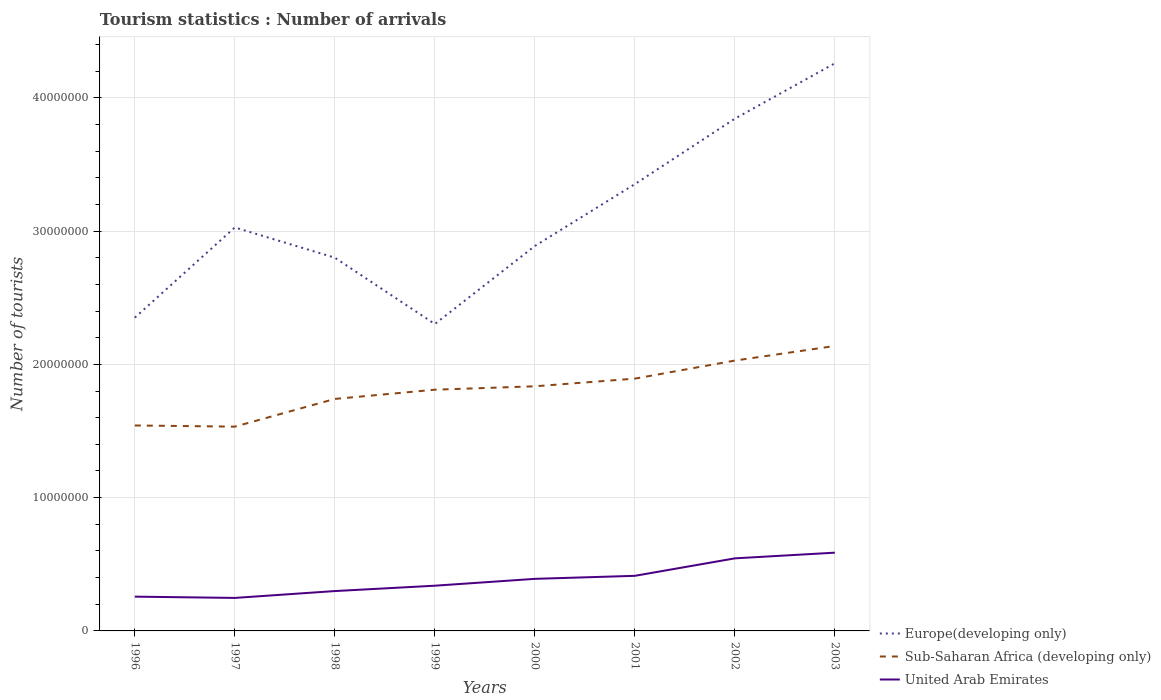Does the line corresponding to Europe(developing only) intersect with the line corresponding to United Arab Emirates?
Make the answer very short. No. Across all years, what is the maximum number of tourist arrivals in United Arab Emirates?
Offer a very short reply. 2.48e+06. In which year was the number of tourist arrivals in Sub-Saharan Africa (developing only) maximum?
Offer a very short reply. 1997. What is the total number of tourist arrivals in United Arab Emirates in the graph?
Offer a terse response. -3.30e+06. What is the difference between the highest and the second highest number of tourist arrivals in Europe(developing only)?
Your response must be concise. 1.96e+07. How many lines are there?
Provide a short and direct response. 3. How many years are there in the graph?
Provide a short and direct response. 8. What is the difference between two consecutive major ticks on the Y-axis?
Keep it short and to the point. 1.00e+07. Are the values on the major ticks of Y-axis written in scientific E-notation?
Make the answer very short. No. Does the graph contain any zero values?
Give a very brief answer. No. Where does the legend appear in the graph?
Your response must be concise. Bottom right. How many legend labels are there?
Your answer should be very brief. 3. How are the legend labels stacked?
Provide a short and direct response. Vertical. What is the title of the graph?
Offer a terse response. Tourism statistics : Number of arrivals. Does "East Asia (developing only)" appear as one of the legend labels in the graph?
Your answer should be compact. No. What is the label or title of the Y-axis?
Provide a succinct answer. Number of tourists. What is the Number of tourists in Europe(developing only) in 1996?
Offer a very short reply. 2.35e+07. What is the Number of tourists in Sub-Saharan Africa (developing only) in 1996?
Keep it short and to the point. 1.54e+07. What is the Number of tourists of United Arab Emirates in 1996?
Keep it short and to the point. 2.57e+06. What is the Number of tourists of Europe(developing only) in 1997?
Provide a short and direct response. 3.03e+07. What is the Number of tourists of Sub-Saharan Africa (developing only) in 1997?
Provide a short and direct response. 1.53e+07. What is the Number of tourists of United Arab Emirates in 1997?
Offer a very short reply. 2.48e+06. What is the Number of tourists of Europe(developing only) in 1998?
Your response must be concise. 2.80e+07. What is the Number of tourists in Sub-Saharan Africa (developing only) in 1998?
Keep it short and to the point. 1.74e+07. What is the Number of tourists in United Arab Emirates in 1998?
Offer a terse response. 2.99e+06. What is the Number of tourists of Europe(developing only) in 1999?
Your response must be concise. 2.30e+07. What is the Number of tourists of Sub-Saharan Africa (developing only) in 1999?
Provide a succinct answer. 1.81e+07. What is the Number of tourists in United Arab Emirates in 1999?
Ensure brevity in your answer.  3.39e+06. What is the Number of tourists of Europe(developing only) in 2000?
Your response must be concise. 2.89e+07. What is the Number of tourists of Sub-Saharan Africa (developing only) in 2000?
Provide a succinct answer. 1.84e+07. What is the Number of tourists of United Arab Emirates in 2000?
Provide a succinct answer. 3.91e+06. What is the Number of tourists in Europe(developing only) in 2001?
Your response must be concise. 3.35e+07. What is the Number of tourists of Sub-Saharan Africa (developing only) in 2001?
Provide a short and direct response. 1.89e+07. What is the Number of tourists of United Arab Emirates in 2001?
Ensure brevity in your answer.  4.13e+06. What is the Number of tourists of Europe(developing only) in 2002?
Your answer should be compact. 3.84e+07. What is the Number of tourists of Sub-Saharan Africa (developing only) in 2002?
Keep it short and to the point. 2.03e+07. What is the Number of tourists in United Arab Emirates in 2002?
Ensure brevity in your answer.  5.44e+06. What is the Number of tourists of Europe(developing only) in 2003?
Make the answer very short. 4.26e+07. What is the Number of tourists of Sub-Saharan Africa (developing only) in 2003?
Keep it short and to the point. 2.14e+07. What is the Number of tourists of United Arab Emirates in 2003?
Offer a terse response. 5.87e+06. Across all years, what is the maximum Number of tourists in Europe(developing only)?
Your answer should be very brief. 4.26e+07. Across all years, what is the maximum Number of tourists of Sub-Saharan Africa (developing only)?
Ensure brevity in your answer.  2.14e+07. Across all years, what is the maximum Number of tourists of United Arab Emirates?
Make the answer very short. 5.87e+06. Across all years, what is the minimum Number of tourists in Europe(developing only)?
Make the answer very short. 2.30e+07. Across all years, what is the minimum Number of tourists of Sub-Saharan Africa (developing only)?
Your answer should be very brief. 1.53e+07. Across all years, what is the minimum Number of tourists of United Arab Emirates?
Give a very brief answer. 2.48e+06. What is the total Number of tourists in Europe(developing only) in the graph?
Offer a very short reply. 2.48e+08. What is the total Number of tourists in Sub-Saharan Africa (developing only) in the graph?
Ensure brevity in your answer.  1.45e+08. What is the total Number of tourists of United Arab Emirates in the graph?
Make the answer very short. 3.08e+07. What is the difference between the Number of tourists in Europe(developing only) in 1996 and that in 1997?
Offer a very short reply. -6.77e+06. What is the difference between the Number of tourists of Sub-Saharan Africa (developing only) in 1996 and that in 1997?
Offer a very short reply. 8.85e+04. What is the difference between the Number of tourists of United Arab Emirates in 1996 and that in 1997?
Give a very brief answer. 9.60e+04. What is the difference between the Number of tourists in Europe(developing only) in 1996 and that in 1998?
Provide a short and direct response. -4.50e+06. What is the difference between the Number of tourists of Sub-Saharan Africa (developing only) in 1996 and that in 1998?
Your answer should be compact. -1.99e+06. What is the difference between the Number of tourists of United Arab Emirates in 1996 and that in 1998?
Your answer should be compact. -4.19e+05. What is the difference between the Number of tourists of Europe(developing only) in 1996 and that in 1999?
Make the answer very short. 4.79e+05. What is the difference between the Number of tourists in Sub-Saharan Africa (developing only) in 1996 and that in 1999?
Give a very brief answer. -2.68e+06. What is the difference between the Number of tourists in United Arab Emirates in 1996 and that in 1999?
Your answer should be compact. -8.21e+05. What is the difference between the Number of tourists in Europe(developing only) in 1996 and that in 2000?
Provide a short and direct response. -5.37e+06. What is the difference between the Number of tourists in Sub-Saharan Africa (developing only) in 1996 and that in 2000?
Your response must be concise. -2.94e+06. What is the difference between the Number of tourists in United Arab Emirates in 1996 and that in 2000?
Your answer should be very brief. -1.34e+06. What is the difference between the Number of tourists in Europe(developing only) in 1996 and that in 2001?
Offer a very short reply. -1.00e+07. What is the difference between the Number of tourists in Sub-Saharan Africa (developing only) in 1996 and that in 2001?
Provide a short and direct response. -3.51e+06. What is the difference between the Number of tourists of United Arab Emirates in 1996 and that in 2001?
Keep it short and to the point. -1.56e+06. What is the difference between the Number of tourists in Europe(developing only) in 1996 and that in 2002?
Keep it short and to the point. -1.49e+07. What is the difference between the Number of tourists in Sub-Saharan Africa (developing only) in 1996 and that in 2002?
Give a very brief answer. -4.87e+06. What is the difference between the Number of tourists in United Arab Emirates in 1996 and that in 2002?
Provide a succinct answer. -2.87e+06. What is the difference between the Number of tourists in Europe(developing only) in 1996 and that in 2003?
Your response must be concise. -1.91e+07. What is the difference between the Number of tourists of Sub-Saharan Africa (developing only) in 1996 and that in 2003?
Provide a short and direct response. -5.96e+06. What is the difference between the Number of tourists of United Arab Emirates in 1996 and that in 2003?
Offer a very short reply. -3.30e+06. What is the difference between the Number of tourists in Europe(developing only) in 1997 and that in 1998?
Make the answer very short. 2.27e+06. What is the difference between the Number of tourists in Sub-Saharan Africa (developing only) in 1997 and that in 1998?
Your answer should be very brief. -2.08e+06. What is the difference between the Number of tourists of United Arab Emirates in 1997 and that in 1998?
Your answer should be compact. -5.15e+05. What is the difference between the Number of tourists of Europe(developing only) in 1997 and that in 1999?
Your answer should be compact. 7.25e+06. What is the difference between the Number of tourists in Sub-Saharan Africa (developing only) in 1997 and that in 1999?
Your answer should be very brief. -2.77e+06. What is the difference between the Number of tourists of United Arab Emirates in 1997 and that in 1999?
Ensure brevity in your answer.  -9.17e+05. What is the difference between the Number of tourists in Europe(developing only) in 1997 and that in 2000?
Ensure brevity in your answer.  1.39e+06. What is the difference between the Number of tourists of Sub-Saharan Africa (developing only) in 1997 and that in 2000?
Give a very brief answer. -3.03e+06. What is the difference between the Number of tourists of United Arab Emirates in 1997 and that in 2000?
Give a very brief answer. -1.43e+06. What is the difference between the Number of tourists in Europe(developing only) in 1997 and that in 2001?
Provide a succinct answer. -3.25e+06. What is the difference between the Number of tourists of Sub-Saharan Africa (developing only) in 1997 and that in 2001?
Your answer should be very brief. -3.60e+06. What is the difference between the Number of tourists of United Arab Emirates in 1997 and that in 2001?
Your answer should be very brief. -1.66e+06. What is the difference between the Number of tourists of Europe(developing only) in 1997 and that in 2002?
Your answer should be compact. -8.16e+06. What is the difference between the Number of tourists in Sub-Saharan Africa (developing only) in 1997 and that in 2002?
Provide a succinct answer. -4.96e+06. What is the difference between the Number of tourists of United Arab Emirates in 1997 and that in 2002?
Offer a very short reply. -2.97e+06. What is the difference between the Number of tourists of Europe(developing only) in 1997 and that in 2003?
Provide a short and direct response. -1.23e+07. What is the difference between the Number of tourists of Sub-Saharan Africa (developing only) in 1997 and that in 2003?
Your answer should be compact. -6.05e+06. What is the difference between the Number of tourists of United Arab Emirates in 1997 and that in 2003?
Offer a terse response. -3.40e+06. What is the difference between the Number of tourists of Europe(developing only) in 1998 and that in 1999?
Your response must be concise. 4.98e+06. What is the difference between the Number of tourists of Sub-Saharan Africa (developing only) in 1998 and that in 1999?
Offer a very short reply. -6.92e+05. What is the difference between the Number of tourists of United Arab Emirates in 1998 and that in 1999?
Your response must be concise. -4.02e+05. What is the difference between the Number of tourists in Europe(developing only) in 1998 and that in 2000?
Provide a short and direct response. -8.76e+05. What is the difference between the Number of tourists in Sub-Saharan Africa (developing only) in 1998 and that in 2000?
Keep it short and to the point. -9.48e+05. What is the difference between the Number of tourists in United Arab Emirates in 1998 and that in 2000?
Make the answer very short. -9.16e+05. What is the difference between the Number of tourists of Europe(developing only) in 1998 and that in 2001?
Give a very brief answer. -5.52e+06. What is the difference between the Number of tourists of Sub-Saharan Africa (developing only) in 1998 and that in 2001?
Ensure brevity in your answer.  -1.52e+06. What is the difference between the Number of tourists of United Arab Emirates in 1998 and that in 2001?
Provide a succinct answer. -1.14e+06. What is the difference between the Number of tourists of Europe(developing only) in 1998 and that in 2002?
Provide a short and direct response. -1.04e+07. What is the difference between the Number of tourists in Sub-Saharan Africa (developing only) in 1998 and that in 2002?
Make the answer very short. -2.88e+06. What is the difference between the Number of tourists in United Arab Emirates in 1998 and that in 2002?
Offer a very short reply. -2.45e+06. What is the difference between the Number of tourists of Europe(developing only) in 1998 and that in 2003?
Provide a short and direct response. -1.46e+07. What is the difference between the Number of tourists in Sub-Saharan Africa (developing only) in 1998 and that in 2003?
Provide a short and direct response. -3.97e+06. What is the difference between the Number of tourists in United Arab Emirates in 1998 and that in 2003?
Keep it short and to the point. -2.88e+06. What is the difference between the Number of tourists in Europe(developing only) in 1999 and that in 2000?
Ensure brevity in your answer.  -5.85e+06. What is the difference between the Number of tourists of Sub-Saharan Africa (developing only) in 1999 and that in 2000?
Your answer should be very brief. -2.56e+05. What is the difference between the Number of tourists in United Arab Emirates in 1999 and that in 2000?
Give a very brief answer. -5.14e+05. What is the difference between the Number of tourists in Europe(developing only) in 1999 and that in 2001?
Your response must be concise. -1.05e+07. What is the difference between the Number of tourists in Sub-Saharan Africa (developing only) in 1999 and that in 2001?
Provide a succinct answer. -8.31e+05. What is the difference between the Number of tourists in United Arab Emirates in 1999 and that in 2001?
Provide a short and direct response. -7.41e+05. What is the difference between the Number of tourists of Europe(developing only) in 1999 and that in 2002?
Keep it short and to the point. -1.54e+07. What is the difference between the Number of tourists of Sub-Saharan Africa (developing only) in 1999 and that in 2002?
Your response must be concise. -2.19e+06. What is the difference between the Number of tourists of United Arab Emirates in 1999 and that in 2002?
Keep it short and to the point. -2.05e+06. What is the difference between the Number of tourists in Europe(developing only) in 1999 and that in 2003?
Offer a terse response. -1.96e+07. What is the difference between the Number of tourists in Sub-Saharan Africa (developing only) in 1999 and that in 2003?
Keep it short and to the point. -3.28e+06. What is the difference between the Number of tourists in United Arab Emirates in 1999 and that in 2003?
Offer a terse response. -2.48e+06. What is the difference between the Number of tourists of Europe(developing only) in 2000 and that in 2001?
Offer a terse response. -4.64e+06. What is the difference between the Number of tourists in Sub-Saharan Africa (developing only) in 2000 and that in 2001?
Ensure brevity in your answer.  -5.75e+05. What is the difference between the Number of tourists in United Arab Emirates in 2000 and that in 2001?
Provide a short and direct response. -2.27e+05. What is the difference between the Number of tourists in Europe(developing only) in 2000 and that in 2002?
Ensure brevity in your answer.  -9.55e+06. What is the difference between the Number of tourists of Sub-Saharan Africa (developing only) in 2000 and that in 2002?
Offer a very short reply. -1.93e+06. What is the difference between the Number of tourists of United Arab Emirates in 2000 and that in 2002?
Ensure brevity in your answer.  -1.54e+06. What is the difference between the Number of tourists in Europe(developing only) in 2000 and that in 2003?
Provide a succinct answer. -1.37e+07. What is the difference between the Number of tourists in Sub-Saharan Africa (developing only) in 2000 and that in 2003?
Make the answer very short. -3.03e+06. What is the difference between the Number of tourists in United Arab Emirates in 2000 and that in 2003?
Offer a very short reply. -1.96e+06. What is the difference between the Number of tourists in Europe(developing only) in 2001 and that in 2002?
Your response must be concise. -4.91e+06. What is the difference between the Number of tourists of Sub-Saharan Africa (developing only) in 2001 and that in 2002?
Provide a succinct answer. -1.35e+06. What is the difference between the Number of tourists of United Arab Emirates in 2001 and that in 2002?
Ensure brevity in your answer.  -1.31e+06. What is the difference between the Number of tourists in Europe(developing only) in 2001 and that in 2003?
Your response must be concise. -9.07e+06. What is the difference between the Number of tourists of Sub-Saharan Africa (developing only) in 2001 and that in 2003?
Provide a short and direct response. -2.45e+06. What is the difference between the Number of tourists in United Arab Emirates in 2001 and that in 2003?
Offer a very short reply. -1.74e+06. What is the difference between the Number of tourists in Europe(developing only) in 2002 and that in 2003?
Offer a very short reply. -4.16e+06. What is the difference between the Number of tourists in Sub-Saharan Africa (developing only) in 2002 and that in 2003?
Keep it short and to the point. -1.10e+06. What is the difference between the Number of tourists in United Arab Emirates in 2002 and that in 2003?
Provide a short and direct response. -4.26e+05. What is the difference between the Number of tourists in Europe(developing only) in 1996 and the Number of tourists in Sub-Saharan Africa (developing only) in 1997?
Make the answer very short. 8.18e+06. What is the difference between the Number of tourists in Europe(developing only) in 1996 and the Number of tourists in United Arab Emirates in 1997?
Your answer should be compact. 2.10e+07. What is the difference between the Number of tourists in Sub-Saharan Africa (developing only) in 1996 and the Number of tourists in United Arab Emirates in 1997?
Keep it short and to the point. 1.29e+07. What is the difference between the Number of tourists in Europe(developing only) in 1996 and the Number of tourists in Sub-Saharan Africa (developing only) in 1998?
Keep it short and to the point. 6.10e+06. What is the difference between the Number of tourists of Europe(developing only) in 1996 and the Number of tourists of United Arab Emirates in 1998?
Offer a very short reply. 2.05e+07. What is the difference between the Number of tourists of Sub-Saharan Africa (developing only) in 1996 and the Number of tourists of United Arab Emirates in 1998?
Make the answer very short. 1.24e+07. What is the difference between the Number of tourists of Europe(developing only) in 1996 and the Number of tourists of Sub-Saharan Africa (developing only) in 1999?
Ensure brevity in your answer.  5.41e+06. What is the difference between the Number of tourists in Europe(developing only) in 1996 and the Number of tourists in United Arab Emirates in 1999?
Provide a succinct answer. 2.01e+07. What is the difference between the Number of tourists of Sub-Saharan Africa (developing only) in 1996 and the Number of tourists of United Arab Emirates in 1999?
Your answer should be compact. 1.20e+07. What is the difference between the Number of tourists in Europe(developing only) in 1996 and the Number of tourists in Sub-Saharan Africa (developing only) in 2000?
Offer a terse response. 5.15e+06. What is the difference between the Number of tourists in Europe(developing only) in 1996 and the Number of tourists in United Arab Emirates in 2000?
Your answer should be very brief. 1.96e+07. What is the difference between the Number of tourists in Sub-Saharan Africa (developing only) in 1996 and the Number of tourists in United Arab Emirates in 2000?
Provide a short and direct response. 1.15e+07. What is the difference between the Number of tourists of Europe(developing only) in 1996 and the Number of tourists of Sub-Saharan Africa (developing only) in 2001?
Offer a terse response. 4.58e+06. What is the difference between the Number of tourists of Europe(developing only) in 1996 and the Number of tourists of United Arab Emirates in 2001?
Your answer should be compact. 1.94e+07. What is the difference between the Number of tourists of Sub-Saharan Africa (developing only) in 1996 and the Number of tourists of United Arab Emirates in 2001?
Your response must be concise. 1.13e+07. What is the difference between the Number of tourists of Europe(developing only) in 1996 and the Number of tourists of Sub-Saharan Africa (developing only) in 2002?
Keep it short and to the point. 3.22e+06. What is the difference between the Number of tourists of Europe(developing only) in 1996 and the Number of tourists of United Arab Emirates in 2002?
Make the answer very short. 1.81e+07. What is the difference between the Number of tourists in Sub-Saharan Africa (developing only) in 1996 and the Number of tourists in United Arab Emirates in 2002?
Your answer should be compact. 9.97e+06. What is the difference between the Number of tourists of Europe(developing only) in 1996 and the Number of tourists of Sub-Saharan Africa (developing only) in 2003?
Make the answer very short. 2.13e+06. What is the difference between the Number of tourists in Europe(developing only) in 1996 and the Number of tourists in United Arab Emirates in 2003?
Ensure brevity in your answer.  1.76e+07. What is the difference between the Number of tourists in Sub-Saharan Africa (developing only) in 1996 and the Number of tourists in United Arab Emirates in 2003?
Keep it short and to the point. 9.54e+06. What is the difference between the Number of tourists in Europe(developing only) in 1997 and the Number of tourists in Sub-Saharan Africa (developing only) in 1998?
Ensure brevity in your answer.  1.29e+07. What is the difference between the Number of tourists in Europe(developing only) in 1997 and the Number of tourists in United Arab Emirates in 1998?
Offer a terse response. 2.73e+07. What is the difference between the Number of tourists of Sub-Saharan Africa (developing only) in 1997 and the Number of tourists of United Arab Emirates in 1998?
Your answer should be compact. 1.23e+07. What is the difference between the Number of tourists of Europe(developing only) in 1997 and the Number of tourists of Sub-Saharan Africa (developing only) in 1999?
Make the answer very short. 1.22e+07. What is the difference between the Number of tourists of Europe(developing only) in 1997 and the Number of tourists of United Arab Emirates in 1999?
Ensure brevity in your answer.  2.69e+07. What is the difference between the Number of tourists in Sub-Saharan Africa (developing only) in 1997 and the Number of tourists in United Arab Emirates in 1999?
Offer a very short reply. 1.19e+07. What is the difference between the Number of tourists in Europe(developing only) in 1997 and the Number of tourists in Sub-Saharan Africa (developing only) in 2000?
Offer a very short reply. 1.19e+07. What is the difference between the Number of tourists in Europe(developing only) in 1997 and the Number of tourists in United Arab Emirates in 2000?
Provide a short and direct response. 2.64e+07. What is the difference between the Number of tourists in Sub-Saharan Africa (developing only) in 1997 and the Number of tourists in United Arab Emirates in 2000?
Provide a succinct answer. 1.14e+07. What is the difference between the Number of tourists of Europe(developing only) in 1997 and the Number of tourists of Sub-Saharan Africa (developing only) in 2001?
Offer a very short reply. 1.13e+07. What is the difference between the Number of tourists in Europe(developing only) in 1997 and the Number of tourists in United Arab Emirates in 2001?
Offer a very short reply. 2.61e+07. What is the difference between the Number of tourists in Sub-Saharan Africa (developing only) in 1997 and the Number of tourists in United Arab Emirates in 2001?
Your answer should be compact. 1.12e+07. What is the difference between the Number of tourists of Europe(developing only) in 1997 and the Number of tourists of Sub-Saharan Africa (developing only) in 2002?
Give a very brief answer. 9.99e+06. What is the difference between the Number of tourists of Europe(developing only) in 1997 and the Number of tourists of United Arab Emirates in 2002?
Offer a terse response. 2.48e+07. What is the difference between the Number of tourists of Sub-Saharan Africa (developing only) in 1997 and the Number of tourists of United Arab Emirates in 2002?
Your response must be concise. 9.88e+06. What is the difference between the Number of tourists in Europe(developing only) in 1997 and the Number of tourists in Sub-Saharan Africa (developing only) in 2003?
Provide a succinct answer. 8.89e+06. What is the difference between the Number of tourists of Europe(developing only) in 1997 and the Number of tourists of United Arab Emirates in 2003?
Provide a short and direct response. 2.44e+07. What is the difference between the Number of tourists in Sub-Saharan Africa (developing only) in 1997 and the Number of tourists in United Arab Emirates in 2003?
Offer a terse response. 9.46e+06. What is the difference between the Number of tourists of Europe(developing only) in 1998 and the Number of tourists of Sub-Saharan Africa (developing only) in 1999?
Provide a succinct answer. 9.91e+06. What is the difference between the Number of tourists of Europe(developing only) in 1998 and the Number of tourists of United Arab Emirates in 1999?
Keep it short and to the point. 2.46e+07. What is the difference between the Number of tourists of Sub-Saharan Africa (developing only) in 1998 and the Number of tourists of United Arab Emirates in 1999?
Offer a very short reply. 1.40e+07. What is the difference between the Number of tourists of Europe(developing only) in 1998 and the Number of tourists of Sub-Saharan Africa (developing only) in 2000?
Make the answer very short. 9.65e+06. What is the difference between the Number of tourists in Europe(developing only) in 1998 and the Number of tourists in United Arab Emirates in 2000?
Give a very brief answer. 2.41e+07. What is the difference between the Number of tourists in Sub-Saharan Africa (developing only) in 1998 and the Number of tourists in United Arab Emirates in 2000?
Provide a short and direct response. 1.35e+07. What is the difference between the Number of tourists of Europe(developing only) in 1998 and the Number of tourists of Sub-Saharan Africa (developing only) in 2001?
Give a very brief answer. 9.07e+06. What is the difference between the Number of tourists of Europe(developing only) in 1998 and the Number of tourists of United Arab Emirates in 2001?
Your response must be concise. 2.39e+07. What is the difference between the Number of tourists in Sub-Saharan Africa (developing only) in 1998 and the Number of tourists in United Arab Emirates in 2001?
Offer a very short reply. 1.33e+07. What is the difference between the Number of tourists in Europe(developing only) in 1998 and the Number of tourists in Sub-Saharan Africa (developing only) in 2002?
Make the answer very short. 7.72e+06. What is the difference between the Number of tourists in Europe(developing only) in 1998 and the Number of tourists in United Arab Emirates in 2002?
Give a very brief answer. 2.26e+07. What is the difference between the Number of tourists in Sub-Saharan Africa (developing only) in 1998 and the Number of tourists in United Arab Emirates in 2002?
Your answer should be compact. 1.20e+07. What is the difference between the Number of tourists in Europe(developing only) in 1998 and the Number of tourists in Sub-Saharan Africa (developing only) in 2003?
Offer a very short reply. 6.62e+06. What is the difference between the Number of tourists in Europe(developing only) in 1998 and the Number of tourists in United Arab Emirates in 2003?
Your answer should be compact. 2.21e+07. What is the difference between the Number of tourists of Sub-Saharan Africa (developing only) in 1998 and the Number of tourists of United Arab Emirates in 2003?
Your answer should be very brief. 1.15e+07. What is the difference between the Number of tourists of Europe(developing only) in 1999 and the Number of tourists of Sub-Saharan Africa (developing only) in 2000?
Provide a short and direct response. 4.67e+06. What is the difference between the Number of tourists of Europe(developing only) in 1999 and the Number of tourists of United Arab Emirates in 2000?
Your response must be concise. 1.91e+07. What is the difference between the Number of tourists of Sub-Saharan Africa (developing only) in 1999 and the Number of tourists of United Arab Emirates in 2000?
Your response must be concise. 1.42e+07. What is the difference between the Number of tourists in Europe(developing only) in 1999 and the Number of tourists in Sub-Saharan Africa (developing only) in 2001?
Make the answer very short. 4.10e+06. What is the difference between the Number of tourists in Europe(developing only) in 1999 and the Number of tourists in United Arab Emirates in 2001?
Provide a succinct answer. 1.89e+07. What is the difference between the Number of tourists of Sub-Saharan Africa (developing only) in 1999 and the Number of tourists of United Arab Emirates in 2001?
Offer a terse response. 1.40e+07. What is the difference between the Number of tourists in Europe(developing only) in 1999 and the Number of tourists in Sub-Saharan Africa (developing only) in 2002?
Your answer should be compact. 2.74e+06. What is the difference between the Number of tourists in Europe(developing only) in 1999 and the Number of tourists in United Arab Emirates in 2002?
Your response must be concise. 1.76e+07. What is the difference between the Number of tourists in Sub-Saharan Africa (developing only) in 1999 and the Number of tourists in United Arab Emirates in 2002?
Keep it short and to the point. 1.27e+07. What is the difference between the Number of tourists in Europe(developing only) in 1999 and the Number of tourists in Sub-Saharan Africa (developing only) in 2003?
Provide a short and direct response. 1.65e+06. What is the difference between the Number of tourists in Europe(developing only) in 1999 and the Number of tourists in United Arab Emirates in 2003?
Keep it short and to the point. 1.72e+07. What is the difference between the Number of tourists of Sub-Saharan Africa (developing only) in 1999 and the Number of tourists of United Arab Emirates in 2003?
Make the answer very short. 1.22e+07. What is the difference between the Number of tourists of Europe(developing only) in 2000 and the Number of tourists of Sub-Saharan Africa (developing only) in 2001?
Your response must be concise. 9.95e+06. What is the difference between the Number of tourists of Europe(developing only) in 2000 and the Number of tourists of United Arab Emirates in 2001?
Ensure brevity in your answer.  2.47e+07. What is the difference between the Number of tourists of Sub-Saharan Africa (developing only) in 2000 and the Number of tourists of United Arab Emirates in 2001?
Ensure brevity in your answer.  1.42e+07. What is the difference between the Number of tourists of Europe(developing only) in 2000 and the Number of tourists of Sub-Saharan Africa (developing only) in 2002?
Your answer should be very brief. 8.60e+06. What is the difference between the Number of tourists in Europe(developing only) in 2000 and the Number of tourists in United Arab Emirates in 2002?
Provide a succinct answer. 2.34e+07. What is the difference between the Number of tourists in Sub-Saharan Africa (developing only) in 2000 and the Number of tourists in United Arab Emirates in 2002?
Offer a terse response. 1.29e+07. What is the difference between the Number of tourists in Europe(developing only) in 2000 and the Number of tourists in Sub-Saharan Africa (developing only) in 2003?
Offer a terse response. 7.50e+06. What is the difference between the Number of tourists of Europe(developing only) in 2000 and the Number of tourists of United Arab Emirates in 2003?
Offer a terse response. 2.30e+07. What is the difference between the Number of tourists in Sub-Saharan Africa (developing only) in 2000 and the Number of tourists in United Arab Emirates in 2003?
Provide a succinct answer. 1.25e+07. What is the difference between the Number of tourists of Europe(developing only) in 2001 and the Number of tourists of Sub-Saharan Africa (developing only) in 2002?
Your answer should be compact. 1.32e+07. What is the difference between the Number of tourists of Europe(developing only) in 2001 and the Number of tourists of United Arab Emirates in 2002?
Offer a very short reply. 2.81e+07. What is the difference between the Number of tourists of Sub-Saharan Africa (developing only) in 2001 and the Number of tourists of United Arab Emirates in 2002?
Keep it short and to the point. 1.35e+07. What is the difference between the Number of tourists of Europe(developing only) in 2001 and the Number of tourists of Sub-Saharan Africa (developing only) in 2003?
Provide a succinct answer. 1.21e+07. What is the difference between the Number of tourists of Europe(developing only) in 2001 and the Number of tourists of United Arab Emirates in 2003?
Give a very brief answer. 2.77e+07. What is the difference between the Number of tourists of Sub-Saharan Africa (developing only) in 2001 and the Number of tourists of United Arab Emirates in 2003?
Provide a succinct answer. 1.31e+07. What is the difference between the Number of tourists of Europe(developing only) in 2002 and the Number of tourists of Sub-Saharan Africa (developing only) in 2003?
Make the answer very short. 1.71e+07. What is the difference between the Number of tourists in Europe(developing only) in 2002 and the Number of tourists in United Arab Emirates in 2003?
Give a very brief answer. 3.26e+07. What is the difference between the Number of tourists of Sub-Saharan Africa (developing only) in 2002 and the Number of tourists of United Arab Emirates in 2003?
Give a very brief answer. 1.44e+07. What is the average Number of tourists in Europe(developing only) per year?
Offer a terse response. 3.10e+07. What is the average Number of tourists of Sub-Saharan Africa (developing only) per year?
Provide a succinct answer. 1.81e+07. What is the average Number of tourists in United Arab Emirates per year?
Ensure brevity in your answer.  3.85e+06. In the year 1996, what is the difference between the Number of tourists of Europe(developing only) and Number of tourists of Sub-Saharan Africa (developing only)?
Your response must be concise. 8.09e+06. In the year 1996, what is the difference between the Number of tourists in Europe(developing only) and Number of tourists in United Arab Emirates?
Ensure brevity in your answer.  2.09e+07. In the year 1996, what is the difference between the Number of tourists in Sub-Saharan Africa (developing only) and Number of tourists in United Arab Emirates?
Offer a very short reply. 1.28e+07. In the year 1997, what is the difference between the Number of tourists in Europe(developing only) and Number of tourists in Sub-Saharan Africa (developing only)?
Ensure brevity in your answer.  1.49e+07. In the year 1997, what is the difference between the Number of tourists of Europe(developing only) and Number of tourists of United Arab Emirates?
Give a very brief answer. 2.78e+07. In the year 1997, what is the difference between the Number of tourists of Sub-Saharan Africa (developing only) and Number of tourists of United Arab Emirates?
Ensure brevity in your answer.  1.29e+07. In the year 1998, what is the difference between the Number of tourists in Europe(developing only) and Number of tourists in Sub-Saharan Africa (developing only)?
Keep it short and to the point. 1.06e+07. In the year 1998, what is the difference between the Number of tourists of Europe(developing only) and Number of tourists of United Arab Emirates?
Give a very brief answer. 2.50e+07. In the year 1998, what is the difference between the Number of tourists in Sub-Saharan Africa (developing only) and Number of tourists in United Arab Emirates?
Your answer should be compact. 1.44e+07. In the year 1999, what is the difference between the Number of tourists of Europe(developing only) and Number of tourists of Sub-Saharan Africa (developing only)?
Your answer should be compact. 4.93e+06. In the year 1999, what is the difference between the Number of tourists in Europe(developing only) and Number of tourists in United Arab Emirates?
Offer a terse response. 1.96e+07. In the year 1999, what is the difference between the Number of tourists of Sub-Saharan Africa (developing only) and Number of tourists of United Arab Emirates?
Ensure brevity in your answer.  1.47e+07. In the year 2000, what is the difference between the Number of tourists in Europe(developing only) and Number of tourists in Sub-Saharan Africa (developing only)?
Offer a very short reply. 1.05e+07. In the year 2000, what is the difference between the Number of tourists of Europe(developing only) and Number of tourists of United Arab Emirates?
Make the answer very short. 2.50e+07. In the year 2000, what is the difference between the Number of tourists of Sub-Saharan Africa (developing only) and Number of tourists of United Arab Emirates?
Keep it short and to the point. 1.44e+07. In the year 2001, what is the difference between the Number of tourists in Europe(developing only) and Number of tourists in Sub-Saharan Africa (developing only)?
Your response must be concise. 1.46e+07. In the year 2001, what is the difference between the Number of tourists in Europe(developing only) and Number of tourists in United Arab Emirates?
Provide a succinct answer. 2.94e+07. In the year 2001, what is the difference between the Number of tourists of Sub-Saharan Africa (developing only) and Number of tourists of United Arab Emirates?
Offer a very short reply. 1.48e+07. In the year 2002, what is the difference between the Number of tourists of Europe(developing only) and Number of tourists of Sub-Saharan Africa (developing only)?
Offer a terse response. 1.81e+07. In the year 2002, what is the difference between the Number of tourists of Europe(developing only) and Number of tourists of United Arab Emirates?
Give a very brief answer. 3.30e+07. In the year 2002, what is the difference between the Number of tourists in Sub-Saharan Africa (developing only) and Number of tourists in United Arab Emirates?
Provide a short and direct response. 1.48e+07. In the year 2003, what is the difference between the Number of tourists of Europe(developing only) and Number of tourists of Sub-Saharan Africa (developing only)?
Ensure brevity in your answer.  2.12e+07. In the year 2003, what is the difference between the Number of tourists of Europe(developing only) and Number of tourists of United Arab Emirates?
Give a very brief answer. 3.67e+07. In the year 2003, what is the difference between the Number of tourists in Sub-Saharan Africa (developing only) and Number of tourists in United Arab Emirates?
Offer a very short reply. 1.55e+07. What is the ratio of the Number of tourists in Europe(developing only) in 1996 to that in 1997?
Keep it short and to the point. 0.78. What is the ratio of the Number of tourists in United Arab Emirates in 1996 to that in 1997?
Give a very brief answer. 1.04. What is the ratio of the Number of tourists of Europe(developing only) in 1996 to that in 1998?
Ensure brevity in your answer.  0.84. What is the ratio of the Number of tourists of Sub-Saharan Africa (developing only) in 1996 to that in 1998?
Provide a short and direct response. 0.89. What is the ratio of the Number of tourists of United Arab Emirates in 1996 to that in 1998?
Provide a short and direct response. 0.86. What is the ratio of the Number of tourists in Europe(developing only) in 1996 to that in 1999?
Ensure brevity in your answer.  1.02. What is the ratio of the Number of tourists of Sub-Saharan Africa (developing only) in 1996 to that in 1999?
Your answer should be compact. 0.85. What is the ratio of the Number of tourists in United Arab Emirates in 1996 to that in 1999?
Give a very brief answer. 0.76. What is the ratio of the Number of tourists in Europe(developing only) in 1996 to that in 2000?
Offer a very short reply. 0.81. What is the ratio of the Number of tourists in Sub-Saharan Africa (developing only) in 1996 to that in 2000?
Ensure brevity in your answer.  0.84. What is the ratio of the Number of tourists in United Arab Emirates in 1996 to that in 2000?
Your response must be concise. 0.66. What is the ratio of the Number of tourists in Europe(developing only) in 1996 to that in 2001?
Your answer should be compact. 0.7. What is the ratio of the Number of tourists of Sub-Saharan Africa (developing only) in 1996 to that in 2001?
Your response must be concise. 0.81. What is the ratio of the Number of tourists of United Arab Emirates in 1996 to that in 2001?
Provide a short and direct response. 0.62. What is the ratio of the Number of tourists in Europe(developing only) in 1996 to that in 2002?
Your answer should be compact. 0.61. What is the ratio of the Number of tourists in Sub-Saharan Africa (developing only) in 1996 to that in 2002?
Ensure brevity in your answer.  0.76. What is the ratio of the Number of tourists in United Arab Emirates in 1996 to that in 2002?
Offer a terse response. 0.47. What is the ratio of the Number of tourists of Europe(developing only) in 1996 to that in 2003?
Provide a short and direct response. 0.55. What is the ratio of the Number of tourists of Sub-Saharan Africa (developing only) in 1996 to that in 2003?
Give a very brief answer. 0.72. What is the ratio of the Number of tourists in United Arab Emirates in 1996 to that in 2003?
Your answer should be compact. 0.44. What is the ratio of the Number of tourists in Europe(developing only) in 1997 to that in 1998?
Keep it short and to the point. 1.08. What is the ratio of the Number of tourists of Sub-Saharan Africa (developing only) in 1997 to that in 1998?
Your answer should be compact. 0.88. What is the ratio of the Number of tourists in United Arab Emirates in 1997 to that in 1998?
Offer a very short reply. 0.83. What is the ratio of the Number of tourists in Europe(developing only) in 1997 to that in 1999?
Your response must be concise. 1.31. What is the ratio of the Number of tourists of Sub-Saharan Africa (developing only) in 1997 to that in 1999?
Your response must be concise. 0.85. What is the ratio of the Number of tourists in United Arab Emirates in 1997 to that in 1999?
Your answer should be very brief. 0.73. What is the ratio of the Number of tourists in Europe(developing only) in 1997 to that in 2000?
Your answer should be very brief. 1.05. What is the ratio of the Number of tourists in Sub-Saharan Africa (developing only) in 1997 to that in 2000?
Offer a terse response. 0.84. What is the ratio of the Number of tourists in United Arab Emirates in 1997 to that in 2000?
Provide a succinct answer. 0.63. What is the ratio of the Number of tourists of Europe(developing only) in 1997 to that in 2001?
Your answer should be very brief. 0.9. What is the ratio of the Number of tourists of Sub-Saharan Africa (developing only) in 1997 to that in 2001?
Make the answer very short. 0.81. What is the ratio of the Number of tourists of United Arab Emirates in 1997 to that in 2001?
Give a very brief answer. 0.6. What is the ratio of the Number of tourists of Europe(developing only) in 1997 to that in 2002?
Your answer should be very brief. 0.79. What is the ratio of the Number of tourists of Sub-Saharan Africa (developing only) in 1997 to that in 2002?
Provide a succinct answer. 0.76. What is the ratio of the Number of tourists of United Arab Emirates in 1997 to that in 2002?
Provide a succinct answer. 0.45. What is the ratio of the Number of tourists of Europe(developing only) in 1997 to that in 2003?
Make the answer very short. 0.71. What is the ratio of the Number of tourists of Sub-Saharan Africa (developing only) in 1997 to that in 2003?
Provide a succinct answer. 0.72. What is the ratio of the Number of tourists in United Arab Emirates in 1997 to that in 2003?
Provide a succinct answer. 0.42. What is the ratio of the Number of tourists of Europe(developing only) in 1998 to that in 1999?
Your answer should be very brief. 1.22. What is the ratio of the Number of tourists of Sub-Saharan Africa (developing only) in 1998 to that in 1999?
Ensure brevity in your answer.  0.96. What is the ratio of the Number of tourists of United Arab Emirates in 1998 to that in 1999?
Offer a terse response. 0.88. What is the ratio of the Number of tourists of Europe(developing only) in 1998 to that in 2000?
Give a very brief answer. 0.97. What is the ratio of the Number of tourists in Sub-Saharan Africa (developing only) in 1998 to that in 2000?
Keep it short and to the point. 0.95. What is the ratio of the Number of tourists in United Arab Emirates in 1998 to that in 2000?
Provide a succinct answer. 0.77. What is the ratio of the Number of tourists in Europe(developing only) in 1998 to that in 2001?
Offer a terse response. 0.84. What is the ratio of the Number of tourists of Sub-Saharan Africa (developing only) in 1998 to that in 2001?
Offer a very short reply. 0.92. What is the ratio of the Number of tourists in United Arab Emirates in 1998 to that in 2001?
Your answer should be compact. 0.72. What is the ratio of the Number of tourists of Europe(developing only) in 1998 to that in 2002?
Provide a succinct answer. 0.73. What is the ratio of the Number of tourists of Sub-Saharan Africa (developing only) in 1998 to that in 2002?
Offer a very short reply. 0.86. What is the ratio of the Number of tourists in United Arab Emirates in 1998 to that in 2002?
Your response must be concise. 0.55. What is the ratio of the Number of tourists of Europe(developing only) in 1998 to that in 2003?
Your answer should be compact. 0.66. What is the ratio of the Number of tourists of Sub-Saharan Africa (developing only) in 1998 to that in 2003?
Your answer should be very brief. 0.81. What is the ratio of the Number of tourists of United Arab Emirates in 1998 to that in 2003?
Provide a short and direct response. 0.51. What is the ratio of the Number of tourists of Europe(developing only) in 1999 to that in 2000?
Your response must be concise. 0.8. What is the ratio of the Number of tourists of Sub-Saharan Africa (developing only) in 1999 to that in 2000?
Provide a short and direct response. 0.99. What is the ratio of the Number of tourists in United Arab Emirates in 1999 to that in 2000?
Keep it short and to the point. 0.87. What is the ratio of the Number of tourists in Europe(developing only) in 1999 to that in 2001?
Offer a terse response. 0.69. What is the ratio of the Number of tourists in Sub-Saharan Africa (developing only) in 1999 to that in 2001?
Your answer should be very brief. 0.96. What is the ratio of the Number of tourists in United Arab Emirates in 1999 to that in 2001?
Keep it short and to the point. 0.82. What is the ratio of the Number of tourists of Europe(developing only) in 1999 to that in 2002?
Offer a very short reply. 0.6. What is the ratio of the Number of tourists in Sub-Saharan Africa (developing only) in 1999 to that in 2002?
Keep it short and to the point. 0.89. What is the ratio of the Number of tourists in United Arab Emirates in 1999 to that in 2002?
Ensure brevity in your answer.  0.62. What is the ratio of the Number of tourists in Europe(developing only) in 1999 to that in 2003?
Your answer should be compact. 0.54. What is the ratio of the Number of tourists of Sub-Saharan Africa (developing only) in 1999 to that in 2003?
Provide a succinct answer. 0.85. What is the ratio of the Number of tourists of United Arab Emirates in 1999 to that in 2003?
Your answer should be very brief. 0.58. What is the ratio of the Number of tourists of Europe(developing only) in 2000 to that in 2001?
Your answer should be very brief. 0.86. What is the ratio of the Number of tourists of Sub-Saharan Africa (developing only) in 2000 to that in 2001?
Offer a terse response. 0.97. What is the ratio of the Number of tourists in United Arab Emirates in 2000 to that in 2001?
Your response must be concise. 0.95. What is the ratio of the Number of tourists in Europe(developing only) in 2000 to that in 2002?
Make the answer very short. 0.75. What is the ratio of the Number of tourists in Sub-Saharan Africa (developing only) in 2000 to that in 2002?
Provide a short and direct response. 0.9. What is the ratio of the Number of tourists of United Arab Emirates in 2000 to that in 2002?
Provide a succinct answer. 0.72. What is the ratio of the Number of tourists of Europe(developing only) in 2000 to that in 2003?
Keep it short and to the point. 0.68. What is the ratio of the Number of tourists of Sub-Saharan Africa (developing only) in 2000 to that in 2003?
Your answer should be very brief. 0.86. What is the ratio of the Number of tourists of United Arab Emirates in 2000 to that in 2003?
Offer a terse response. 0.67. What is the ratio of the Number of tourists of Europe(developing only) in 2001 to that in 2002?
Ensure brevity in your answer.  0.87. What is the ratio of the Number of tourists of Sub-Saharan Africa (developing only) in 2001 to that in 2002?
Offer a terse response. 0.93. What is the ratio of the Number of tourists of United Arab Emirates in 2001 to that in 2002?
Keep it short and to the point. 0.76. What is the ratio of the Number of tourists in Europe(developing only) in 2001 to that in 2003?
Keep it short and to the point. 0.79. What is the ratio of the Number of tourists of Sub-Saharan Africa (developing only) in 2001 to that in 2003?
Ensure brevity in your answer.  0.89. What is the ratio of the Number of tourists in United Arab Emirates in 2001 to that in 2003?
Your answer should be compact. 0.7. What is the ratio of the Number of tourists in Europe(developing only) in 2002 to that in 2003?
Offer a very short reply. 0.9. What is the ratio of the Number of tourists of Sub-Saharan Africa (developing only) in 2002 to that in 2003?
Ensure brevity in your answer.  0.95. What is the ratio of the Number of tourists in United Arab Emirates in 2002 to that in 2003?
Offer a very short reply. 0.93. What is the difference between the highest and the second highest Number of tourists of Europe(developing only)?
Make the answer very short. 4.16e+06. What is the difference between the highest and the second highest Number of tourists in Sub-Saharan Africa (developing only)?
Make the answer very short. 1.10e+06. What is the difference between the highest and the second highest Number of tourists in United Arab Emirates?
Offer a terse response. 4.26e+05. What is the difference between the highest and the lowest Number of tourists in Europe(developing only)?
Make the answer very short. 1.96e+07. What is the difference between the highest and the lowest Number of tourists of Sub-Saharan Africa (developing only)?
Keep it short and to the point. 6.05e+06. What is the difference between the highest and the lowest Number of tourists in United Arab Emirates?
Your answer should be very brief. 3.40e+06. 